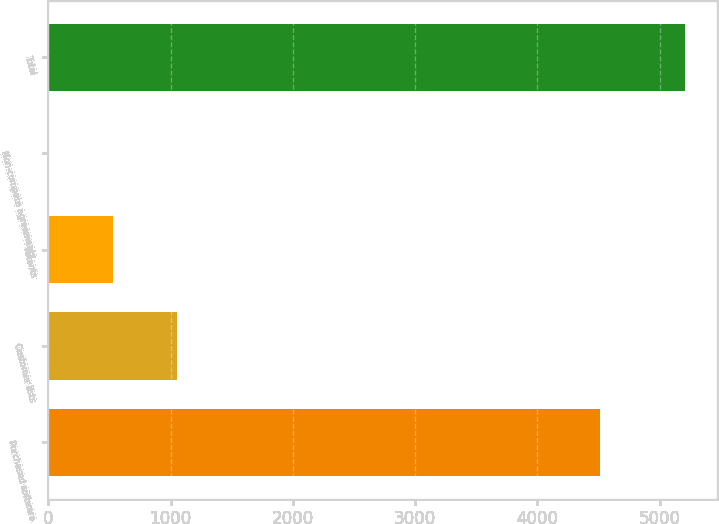Convert chart to OTSL. <chart><loc_0><loc_0><loc_500><loc_500><bar_chart><fcel>Purchased software<fcel>Customer lists<fcel>Patents<fcel>Non-compete agreements<fcel>Total<nl><fcel>4508<fcel>1049.4<fcel>529.2<fcel>9<fcel>5211<nl></chart> 